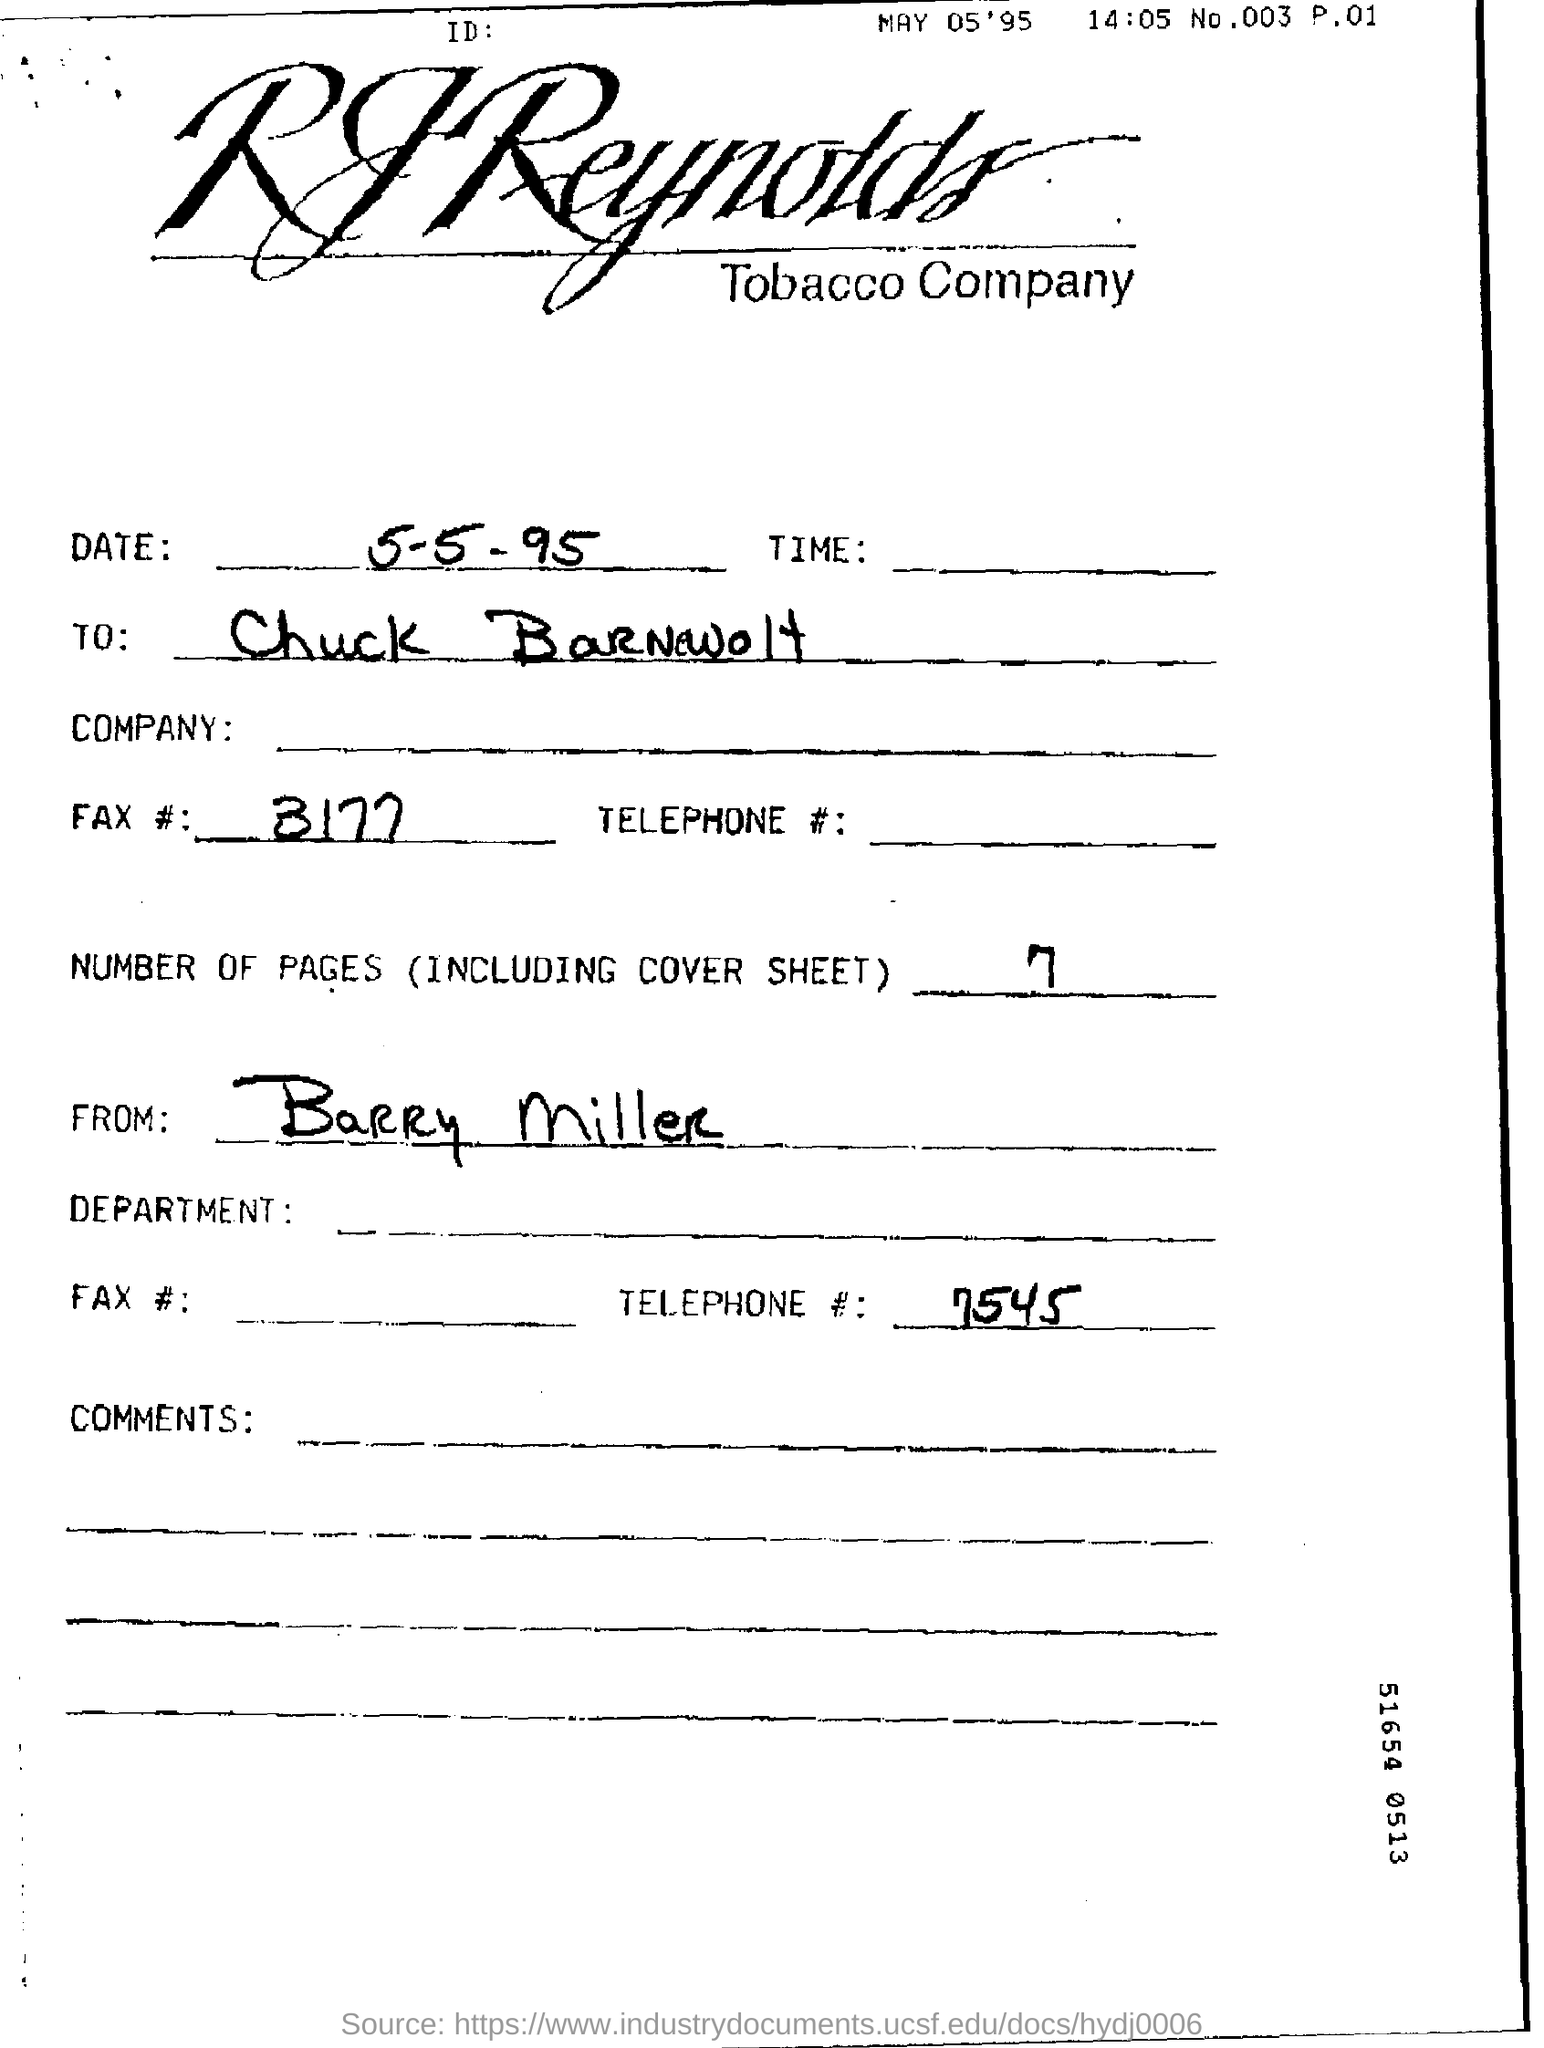Identify some key points in this picture. The fax number mentioned in this context is 3177... The telephone number mentioned in this document is 7545.... The RJ Reynolds Tobacco Company is mentioned in this document. The number of pages in the document, including the cover sheet, is seven. The document mentions a date of May 05'95. 